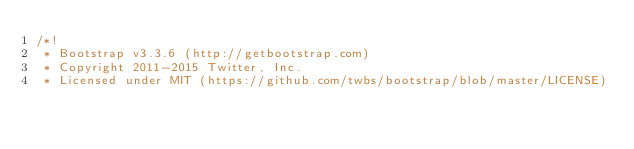<code> <loc_0><loc_0><loc_500><loc_500><_CSS_>/*!
 * Bootstrap v3.3.6 (http://getbootstrap.com)
 * Copyright 2011-2015 Twitter, Inc.
 * Licensed under MIT (https://github.com/twbs/bootstrap/blob/master/LICENSE)</code> 